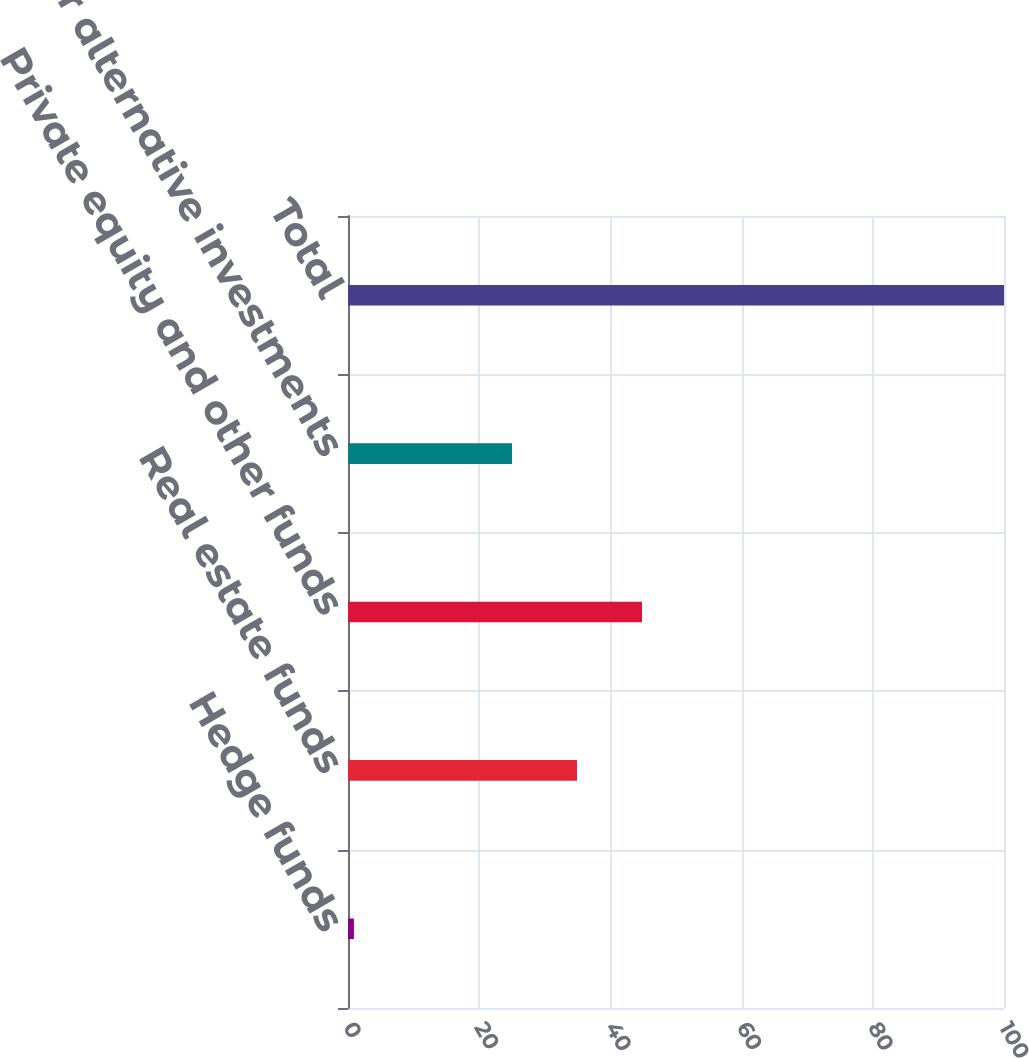Convert chart to OTSL. <chart><loc_0><loc_0><loc_500><loc_500><bar_chart><fcel>Hedge funds<fcel>Real estate funds<fcel>Private equity and other funds<fcel>Other alternative investments<fcel>Total<nl><fcel>0.9<fcel>34.91<fcel>44.82<fcel>25<fcel>100<nl></chart> 